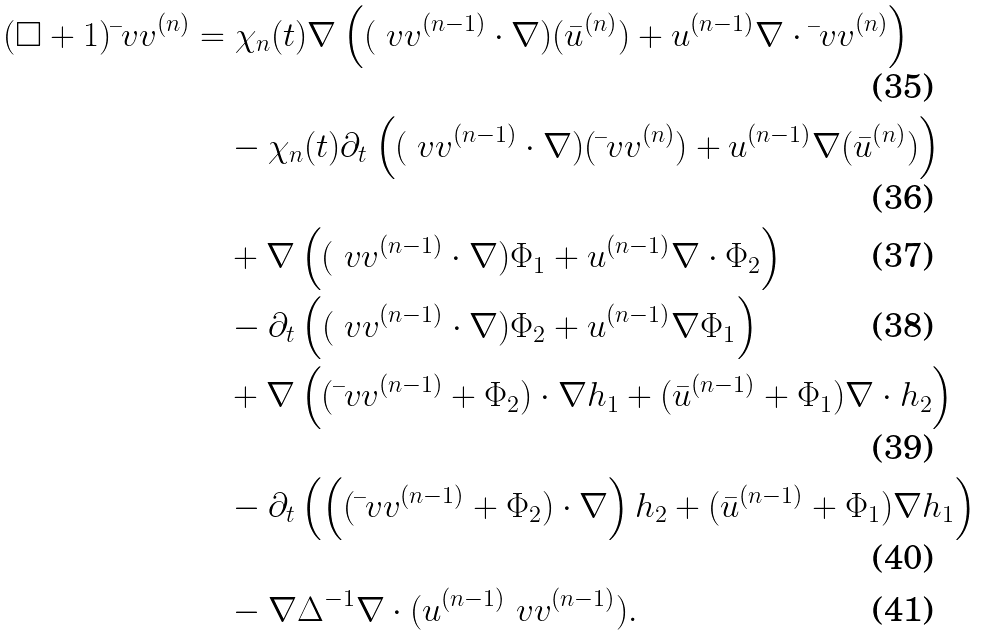Convert formula to latex. <formula><loc_0><loc_0><loc_500><loc_500>( \square + 1 ) \bar { \ } v v ^ { ( n ) } & = \chi _ { n } ( t ) \nabla \left ( ( \ v v ^ { ( n - 1 ) } \cdot \nabla ) ( \bar { u } ^ { ( n ) } ) + u ^ { ( n - 1 ) } \nabla \cdot \bar { \ } v v ^ { ( n ) } \right ) \\ & \quad - \chi _ { n } ( t ) \partial _ { t } \left ( ( \ v v ^ { ( n - 1 ) } \cdot \nabla ) ( \bar { \ } v v ^ { ( n ) } ) + u ^ { ( n - 1 ) } \nabla ( \bar { u } ^ { ( n ) } ) \right ) \\ & \quad + \nabla \left ( ( \ v v ^ { ( n - 1 ) } \cdot \nabla ) \Phi _ { 1 } + u ^ { ( n - 1 ) } \nabla \cdot \Phi _ { 2 } \right ) \\ & \quad - \partial _ { t } \left ( ( \ v v ^ { ( n - 1 ) } \cdot \nabla ) \Phi _ { 2 } + u ^ { ( n - 1 ) } \nabla \Phi _ { 1 } \right ) \\ & \quad + \nabla \left ( ( \bar { \ } v v ^ { ( n - 1 ) } + \Phi _ { 2 } ) \cdot \nabla h _ { 1 } + ( \bar { u } ^ { ( n - 1 ) } + \Phi _ { 1 } ) \nabla \cdot h _ { 2 } \right ) \\ & \quad - \partial _ { t } \left ( \left ( ( \bar { \ } v v ^ { ( n - 1 ) } + \Phi _ { 2 } ) \cdot \nabla \right ) h _ { 2 } + ( \bar { u } ^ { ( n - 1 ) } + \Phi _ { 1 } ) \nabla h _ { 1 } \right ) \\ & \quad - \nabla \Delta ^ { - 1 } \nabla \cdot ( u ^ { ( n - 1 ) } \ v v ^ { ( n - 1 ) } ) .</formula> 